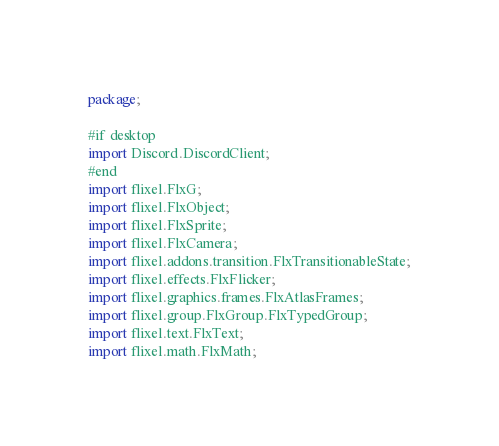<code> <loc_0><loc_0><loc_500><loc_500><_Haxe_>package;

#if desktop
import Discord.DiscordClient;
#end
import flixel.FlxG;
import flixel.FlxObject;
import flixel.FlxSprite;
import flixel.FlxCamera;
import flixel.addons.transition.FlxTransitionableState;
import flixel.effects.FlxFlicker;
import flixel.graphics.frames.FlxAtlasFrames;
import flixel.group.FlxGroup.FlxTypedGroup;
import flixel.text.FlxText;
import flixel.math.FlxMath;</code> 